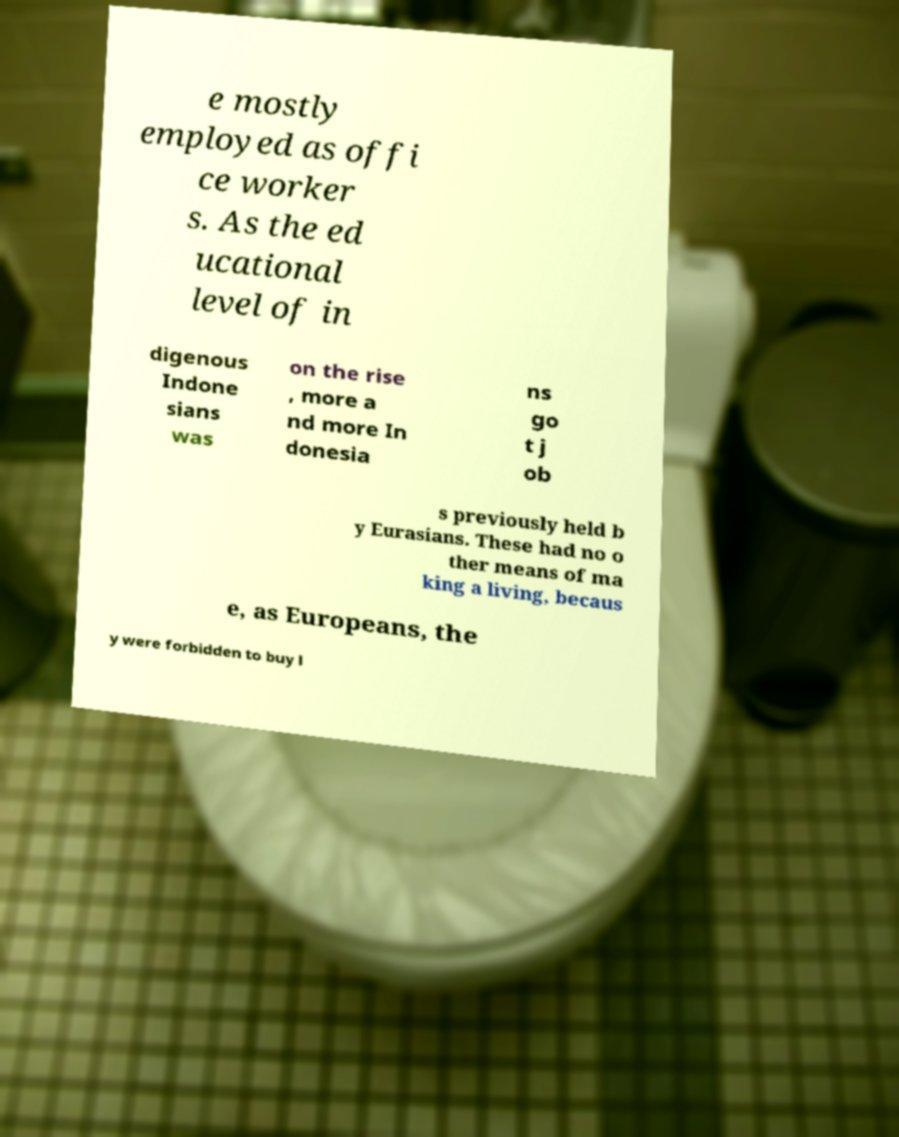There's text embedded in this image that I need extracted. Can you transcribe it verbatim? e mostly employed as offi ce worker s. As the ed ucational level of in digenous Indone sians was on the rise , more a nd more In donesia ns go t j ob s previously held b y Eurasians. These had no o ther means of ma king a living, becaus e, as Europeans, the y were forbidden to buy l 